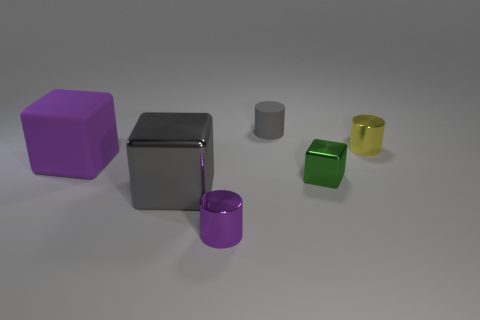How many shiny objects have the same color as the big shiny cube?
Offer a terse response. 0. Is the material of the small object that is in front of the small green metallic cube the same as the tiny gray thing?
Offer a terse response. No. The big gray metallic thing is what shape?
Your answer should be very brief. Cube. What number of green things are either large rubber things or tiny metal things?
Keep it short and to the point. 1. How many other things are there of the same material as the tiny gray object?
Ensure brevity in your answer.  1. Do the small thing left of the tiny gray matte cylinder and the tiny gray matte thing have the same shape?
Provide a succinct answer. Yes. Is there a large metal thing?
Offer a terse response. Yes. Are there more metal things on the left side of the small gray thing than small gray cylinders?
Give a very brief answer. Yes. There is a big gray object; are there any things behind it?
Offer a very short reply. Yes. Do the green metallic block and the gray metallic thing have the same size?
Keep it short and to the point. No. 